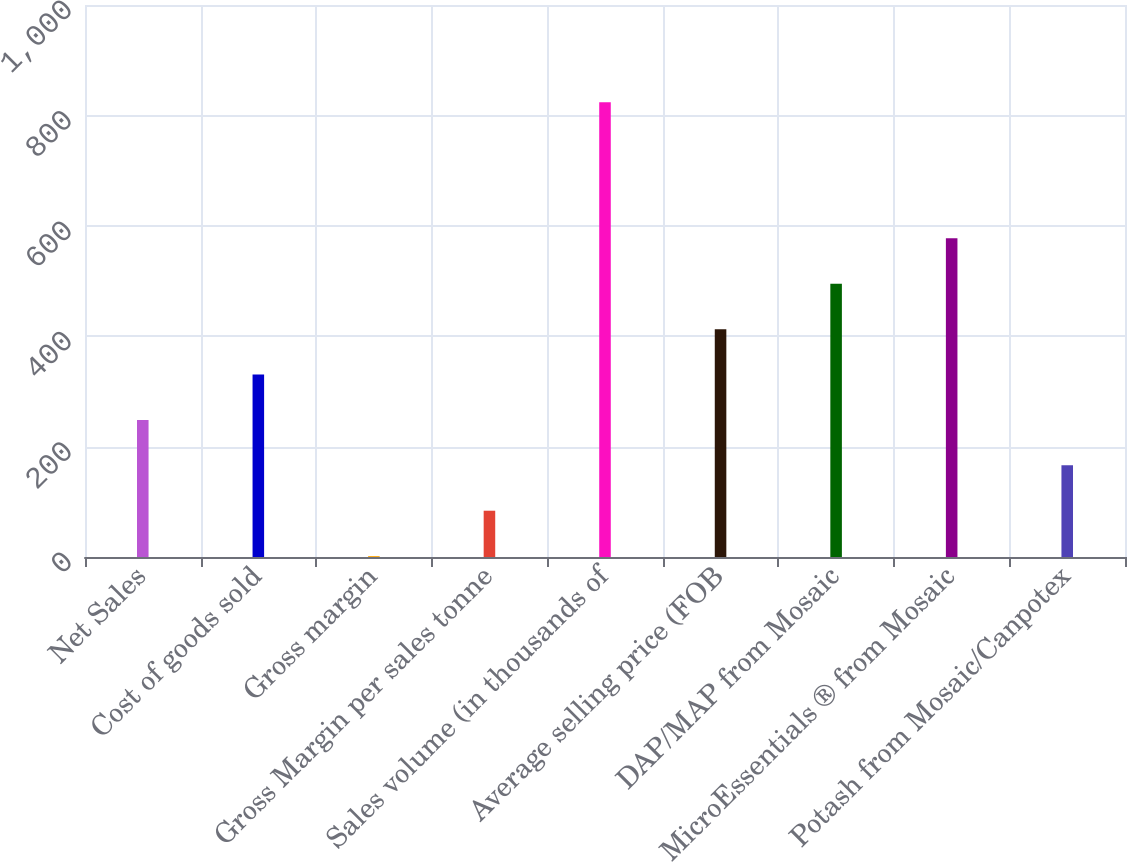Convert chart to OTSL. <chart><loc_0><loc_0><loc_500><loc_500><bar_chart><fcel>Net Sales<fcel>Cost of goods sold<fcel>Gross margin<fcel>Gross Margin per sales tonne<fcel>Sales volume (in thousands of<fcel>Average selling price (FOB<fcel>DAP/MAP from Mosaic<fcel>MicroEssentials ® from Mosaic<fcel>Potash from Mosaic/Canpotex<nl><fcel>248.32<fcel>330.56<fcel>1.6<fcel>83.84<fcel>824<fcel>412.8<fcel>495.04<fcel>577.28<fcel>166.08<nl></chart> 